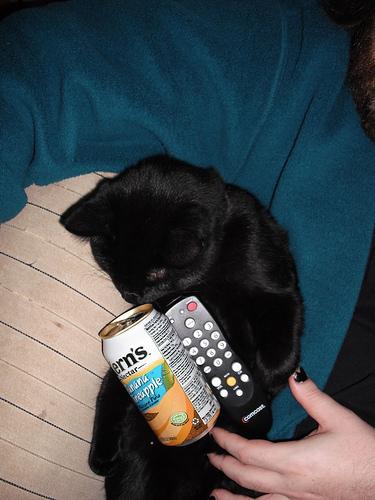What color is the cat?
Quick response, please. Black. What is the cat sitting on?
Be succinct. Couch. What color are the buttons on the remote?
Give a very brief answer. White. 